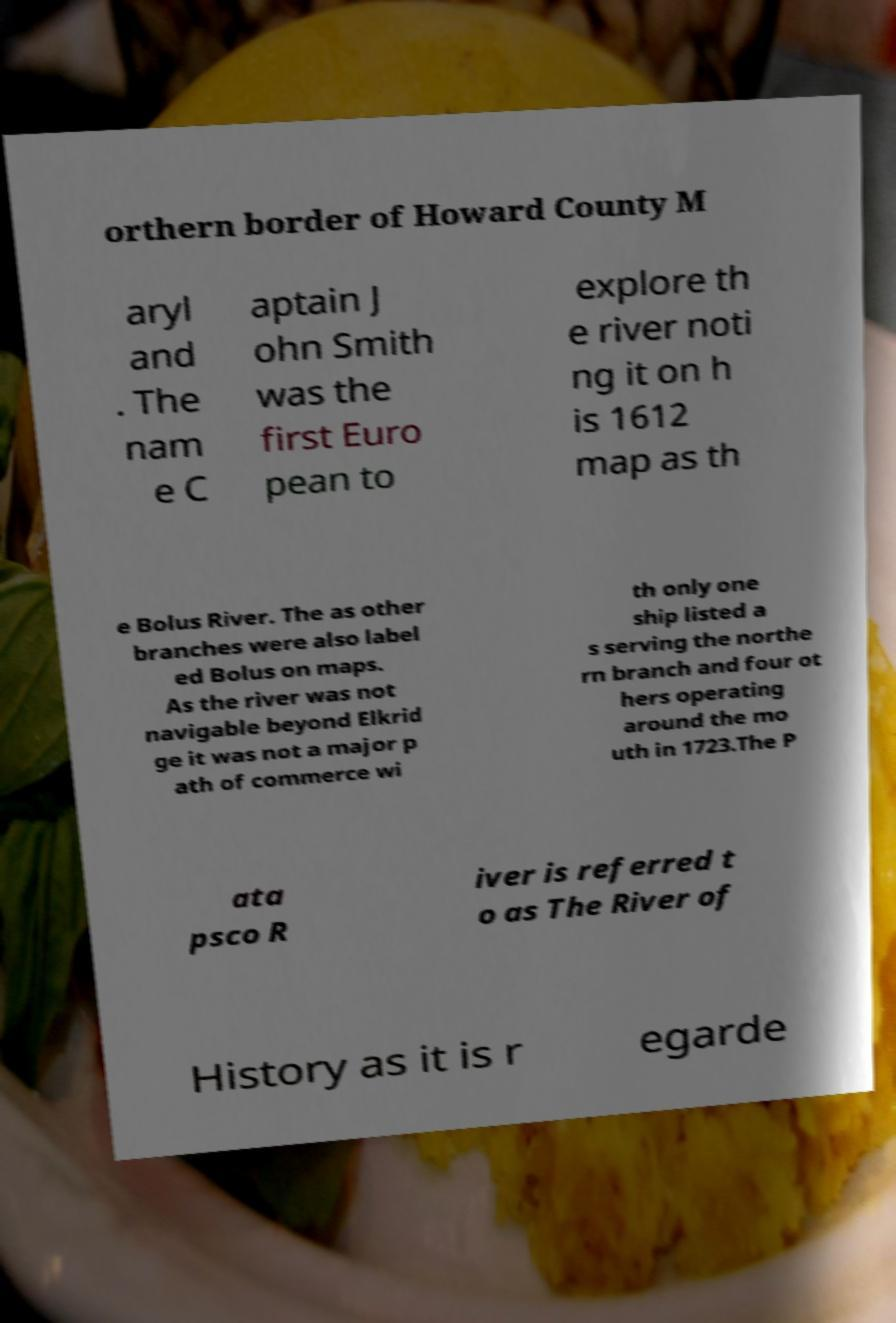Please identify and transcribe the text found in this image. orthern border of Howard County M aryl and . The nam e C aptain J ohn Smith was the first Euro pean to explore th e river noti ng it on h is 1612 map as th e Bolus River. The as other branches were also label ed Bolus on maps. As the river was not navigable beyond Elkrid ge it was not a major p ath of commerce wi th only one ship listed a s serving the northe rn branch and four ot hers operating around the mo uth in 1723.The P ata psco R iver is referred t o as The River of History as it is r egarde 